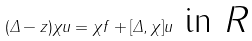<formula> <loc_0><loc_0><loc_500><loc_500>( \Delta - z ) \chi u = \chi f + [ \Delta , \chi ] u \text { in $R$}</formula> 